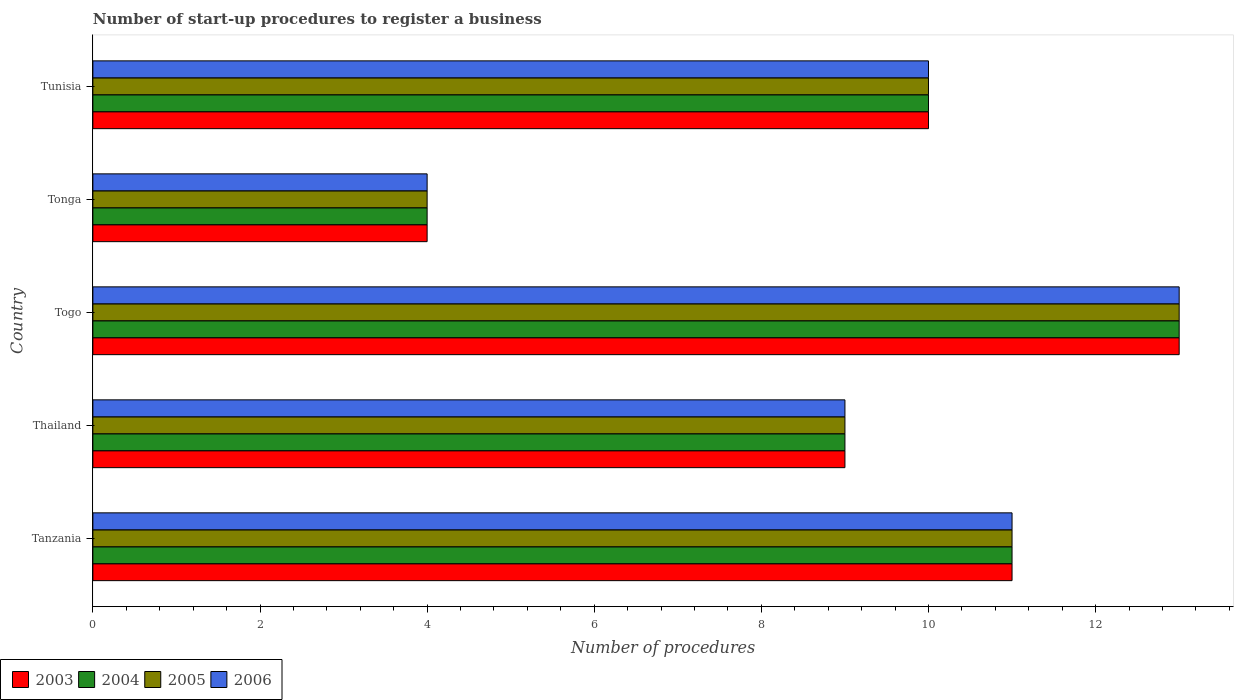How many groups of bars are there?
Your answer should be compact. 5. Are the number of bars per tick equal to the number of legend labels?
Give a very brief answer. Yes. How many bars are there on the 1st tick from the top?
Keep it short and to the point. 4. What is the label of the 5th group of bars from the top?
Offer a terse response. Tanzania. In how many cases, is the number of bars for a given country not equal to the number of legend labels?
Make the answer very short. 0. In which country was the number of procedures required to register a business in 2004 maximum?
Ensure brevity in your answer.  Togo. In which country was the number of procedures required to register a business in 2003 minimum?
Give a very brief answer. Tonga. What is the average number of procedures required to register a business in 2004 per country?
Give a very brief answer. 9.4. What is the difference between the number of procedures required to register a business in 2003 and number of procedures required to register a business in 2004 in Tunisia?
Offer a terse response. 0. Is the number of procedures required to register a business in 2005 in Tanzania less than that in Tunisia?
Ensure brevity in your answer.  No. Is the difference between the number of procedures required to register a business in 2003 in Tonga and Tunisia greater than the difference between the number of procedures required to register a business in 2004 in Tonga and Tunisia?
Your response must be concise. No. In how many countries, is the number of procedures required to register a business in 2006 greater than the average number of procedures required to register a business in 2006 taken over all countries?
Your answer should be compact. 3. What does the 3rd bar from the bottom in Tonga represents?
Offer a terse response. 2005. Is it the case that in every country, the sum of the number of procedures required to register a business in 2003 and number of procedures required to register a business in 2006 is greater than the number of procedures required to register a business in 2004?
Ensure brevity in your answer.  Yes. Are all the bars in the graph horizontal?
Your answer should be compact. Yes. Are the values on the major ticks of X-axis written in scientific E-notation?
Provide a short and direct response. No. Does the graph contain grids?
Your response must be concise. No. What is the title of the graph?
Make the answer very short. Number of start-up procedures to register a business. Does "1971" appear as one of the legend labels in the graph?
Ensure brevity in your answer.  No. What is the label or title of the X-axis?
Provide a short and direct response. Number of procedures. What is the Number of procedures in 2004 in Tanzania?
Ensure brevity in your answer.  11. What is the Number of procedures in 2005 in Thailand?
Offer a very short reply. 9. What is the Number of procedures of 2006 in Thailand?
Offer a very short reply. 9. What is the Number of procedures of 2003 in Togo?
Provide a succinct answer. 13. What is the Number of procedures of 2004 in Togo?
Ensure brevity in your answer.  13. What is the Number of procedures of 2006 in Togo?
Provide a short and direct response. 13. What is the Number of procedures in 2004 in Tonga?
Give a very brief answer. 4. What is the Number of procedures in 2005 in Tonga?
Provide a short and direct response. 4. What is the Number of procedures in 2006 in Tonga?
Give a very brief answer. 4. What is the Number of procedures of 2003 in Tunisia?
Provide a succinct answer. 10. Across all countries, what is the maximum Number of procedures of 2005?
Your response must be concise. 13. Across all countries, what is the maximum Number of procedures of 2006?
Give a very brief answer. 13. Across all countries, what is the minimum Number of procedures in 2003?
Ensure brevity in your answer.  4. Across all countries, what is the minimum Number of procedures of 2005?
Offer a terse response. 4. Across all countries, what is the minimum Number of procedures of 2006?
Provide a short and direct response. 4. What is the total Number of procedures of 2003 in the graph?
Provide a short and direct response. 47. What is the total Number of procedures of 2005 in the graph?
Offer a very short reply. 47. What is the difference between the Number of procedures in 2003 in Tanzania and that in Thailand?
Provide a short and direct response. 2. What is the difference between the Number of procedures of 2005 in Tanzania and that in Thailand?
Keep it short and to the point. 2. What is the difference between the Number of procedures in 2006 in Tanzania and that in Thailand?
Your response must be concise. 2. What is the difference between the Number of procedures of 2003 in Tanzania and that in Tonga?
Your answer should be compact. 7. What is the difference between the Number of procedures of 2005 in Tanzania and that in Tonga?
Your answer should be very brief. 7. What is the difference between the Number of procedures in 2006 in Tanzania and that in Tonga?
Give a very brief answer. 7. What is the difference between the Number of procedures in 2004 in Tanzania and that in Tunisia?
Offer a terse response. 1. What is the difference between the Number of procedures of 2005 in Tanzania and that in Tunisia?
Offer a very short reply. 1. What is the difference between the Number of procedures of 2006 in Tanzania and that in Tunisia?
Provide a short and direct response. 1. What is the difference between the Number of procedures in 2003 in Thailand and that in Togo?
Give a very brief answer. -4. What is the difference between the Number of procedures in 2006 in Thailand and that in Togo?
Your answer should be very brief. -4. What is the difference between the Number of procedures of 2006 in Thailand and that in Tunisia?
Give a very brief answer. -1. What is the difference between the Number of procedures of 2003 in Togo and that in Tonga?
Provide a short and direct response. 9. What is the difference between the Number of procedures in 2003 in Togo and that in Tunisia?
Provide a succinct answer. 3. What is the difference between the Number of procedures in 2005 in Togo and that in Tunisia?
Make the answer very short. 3. What is the difference between the Number of procedures in 2004 in Tonga and that in Tunisia?
Your response must be concise. -6. What is the difference between the Number of procedures of 2005 in Tonga and that in Tunisia?
Offer a very short reply. -6. What is the difference between the Number of procedures in 2003 in Tanzania and the Number of procedures in 2004 in Thailand?
Provide a succinct answer. 2. What is the difference between the Number of procedures of 2005 in Tanzania and the Number of procedures of 2006 in Thailand?
Your answer should be compact. 2. What is the difference between the Number of procedures of 2003 in Tanzania and the Number of procedures of 2004 in Togo?
Offer a terse response. -2. What is the difference between the Number of procedures in 2003 in Tanzania and the Number of procedures in 2005 in Togo?
Provide a short and direct response. -2. What is the difference between the Number of procedures in 2003 in Tanzania and the Number of procedures in 2006 in Togo?
Provide a short and direct response. -2. What is the difference between the Number of procedures of 2004 in Tanzania and the Number of procedures of 2005 in Togo?
Your answer should be compact. -2. What is the difference between the Number of procedures in 2003 in Tanzania and the Number of procedures in 2006 in Tonga?
Your response must be concise. 7. What is the difference between the Number of procedures of 2004 in Tanzania and the Number of procedures of 2005 in Tonga?
Provide a succinct answer. 7. What is the difference between the Number of procedures in 2003 in Tanzania and the Number of procedures in 2006 in Tunisia?
Make the answer very short. 1. What is the difference between the Number of procedures of 2005 in Tanzania and the Number of procedures of 2006 in Tunisia?
Offer a terse response. 1. What is the difference between the Number of procedures in 2003 in Thailand and the Number of procedures in 2004 in Togo?
Offer a terse response. -4. What is the difference between the Number of procedures of 2003 in Thailand and the Number of procedures of 2005 in Togo?
Ensure brevity in your answer.  -4. What is the difference between the Number of procedures of 2003 in Thailand and the Number of procedures of 2006 in Togo?
Ensure brevity in your answer.  -4. What is the difference between the Number of procedures in 2004 in Thailand and the Number of procedures in 2006 in Togo?
Your response must be concise. -4. What is the difference between the Number of procedures of 2003 in Thailand and the Number of procedures of 2006 in Tonga?
Provide a short and direct response. 5. What is the difference between the Number of procedures of 2004 in Thailand and the Number of procedures of 2005 in Tonga?
Ensure brevity in your answer.  5. What is the difference between the Number of procedures in 2004 in Thailand and the Number of procedures in 2006 in Tonga?
Offer a terse response. 5. What is the difference between the Number of procedures of 2005 in Thailand and the Number of procedures of 2006 in Tonga?
Your answer should be very brief. 5. What is the difference between the Number of procedures in 2003 in Thailand and the Number of procedures in 2004 in Tunisia?
Provide a succinct answer. -1. What is the difference between the Number of procedures in 2003 in Thailand and the Number of procedures in 2005 in Tunisia?
Offer a terse response. -1. What is the difference between the Number of procedures in 2003 in Togo and the Number of procedures in 2004 in Tonga?
Make the answer very short. 9. What is the difference between the Number of procedures in 2003 in Togo and the Number of procedures in 2006 in Tonga?
Ensure brevity in your answer.  9. What is the difference between the Number of procedures of 2005 in Togo and the Number of procedures of 2006 in Tonga?
Offer a terse response. 9. What is the difference between the Number of procedures of 2003 in Togo and the Number of procedures of 2005 in Tunisia?
Offer a very short reply. 3. What is the difference between the Number of procedures of 2004 in Togo and the Number of procedures of 2005 in Tunisia?
Your answer should be very brief. 3. What is the difference between the Number of procedures in 2005 in Togo and the Number of procedures in 2006 in Tunisia?
Your answer should be very brief. 3. What is the difference between the Number of procedures of 2003 in Tonga and the Number of procedures of 2004 in Tunisia?
Provide a succinct answer. -6. What is the average Number of procedures of 2004 per country?
Offer a terse response. 9.4. What is the average Number of procedures of 2006 per country?
Keep it short and to the point. 9.4. What is the difference between the Number of procedures in 2003 and Number of procedures in 2004 in Tanzania?
Offer a very short reply. 0. What is the difference between the Number of procedures of 2003 and Number of procedures of 2005 in Tanzania?
Provide a short and direct response. 0. What is the difference between the Number of procedures of 2003 and Number of procedures of 2006 in Tanzania?
Provide a succinct answer. 0. What is the difference between the Number of procedures of 2004 and Number of procedures of 2006 in Tanzania?
Your response must be concise. 0. What is the difference between the Number of procedures of 2003 and Number of procedures of 2005 in Thailand?
Keep it short and to the point. 0. What is the difference between the Number of procedures in 2004 and Number of procedures in 2005 in Thailand?
Your answer should be compact. 0. What is the difference between the Number of procedures in 2004 and Number of procedures in 2006 in Thailand?
Provide a short and direct response. 0. What is the difference between the Number of procedures of 2004 and Number of procedures of 2006 in Togo?
Your response must be concise. 0. What is the difference between the Number of procedures of 2003 and Number of procedures of 2004 in Tonga?
Offer a very short reply. 0. What is the difference between the Number of procedures in 2003 and Number of procedures in 2005 in Tonga?
Keep it short and to the point. 0. What is the difference between the Number of procedures of 2003 and Number of procedures of 2006 in Tonga?
Your answer should be compact. 0. What is the difference between the Number of procedures in 2005 and Number of procedures in 2006 in Tonga?
Make the answer very short. 0. What is the difference between the Number of procedures of 2004 and Number of procedures of 2005 in Tunisia?
Give a very brief answer. 0. What is the difference between the Number of procedures of 2004 and Number of procedures of 2006 in Tunisia?
Provide a short and direct response. 0. What is the difference between the Number of procedures of 2005 and Number of procedures of 2006 in Tunisia?
Ensure brevity in your answer.  0. What is the ratio of the Number of procedures in 2003 in Tanzania to that in Thailand?
Offer a terse response. 1.22. What is the ratio of the Number of procedures of 2004 in Tanzania to that in Thailand?
Offer a terse response. 1.22. What is the ratio of the Number of procedures of 2005 in Tanzania to that in Thailand?
Provide a short and direct response. 1.22. What is the ratio of the Number of procedures of 2006 in Tanzania to that in Thailand?
Offer a very short reply. 1.22. What is the ratio of the Number of procedures in 2003 in Tanzania to that in Togo?
Provide a succinct answer. 0.85. What is the ratio of the Number of procedures in 2004 in Tanzania to that in Togo?
Keep it short and to the point. 0.85. What is the ratio of the Number of procedures of 2005 in Tanzania to that in Togo?
Keep it short and to the point. 0.85. What is the ratio of the Number of procedures of 2006 in Tanzania to that in Togo?
Your response must be concise. 0.85. What is the ratio of the Number of procedures in 2003 in Tanzania to that in Tonga?
Provide a short and direct response. 2.75. What is the ratio of the Number of procedures in 2004 in Tanzania to that in Tonga?
Provide a succinct answer. 2.75. What is the ratio of the Number of procedures of 2005 in Tanzania to that in Tonga?
Keep it short and to the point. 2.75. What is the ratio of the Number of procedures in 2006 in Tanzania to that in Tonga?
Your response must be concise. 2.75. What is the ratio of the Number of procedures in 2006 in Tanzania to that in Tunisia?
Offer a very short reply. 1.1. What is the ratio of the Number of procedures in 2003 in Thailand to that in Togo?
Give a very brief answer. 0.69. What is the ratio of the Number of procedures of 2004 in Thailand to that in Togo?
Your answer should be compact. 0.69. What is the ratio of the Number of procedures in 2005 in Thailand to that in Togo?
Your answer should be compact. 0.69. What is the ratio of the Number of procedures of 2006 in Thailand to that in Togo?
Ensure brevity in your answer.  0.69. What is the ratio of the Number of procedures of 2003 in Thailand to that in Tonga?
Give a very brief answer. 2.25. What is the ratio of the Number of procedures of 2004 in Thailand to that in Tonga?
Offer a terse response. 2.25. What is the ratio of the Number of procedures of 2005 in Thailand to that in Tonga?
Provide a succinct answer. 2.25. What is the ratio of the Number of procedures of 2006 in Thailand to that in Tonga?
Your answer should be compact. 2.25. What is the ratio of the Number of procedures of 2003 in Thailand to that in Tunisia?
Make the answer very short. 0.9. What is the ratio of the Number of procedures of 2005 in Thailand to that in Tunisia?
Offer a very short reply. 0.9. What is the ratio of the Number of procedures of 2006 in Thailand to that in Tunisia?
Make the answer very short. 0.9. What is the ratio of the Number of procedures in 2005 in Togo to that in Tonga?
Offer a terse response. 3.25. What is the ratio of the Number of procedures of 2006 in Togo to that in Tonga?
Make the answer very short. 3.25. What is the ratio of the Number of procedures of 2003 in Togo to that in Tunisia?
Keep it short and to the point. 1.3. What is the ratio of the Number of procedures in 2004 in Togo to that in Tunisia?
Your answer should be compact. 1.3. What is the ratio of the Number of procedures in 2005 in Tonga to that in Tunisia?
Offer a terse response. 0.4. What is the ratio of the Number of procedures of 2006 in Tonga to that in Tunisia?
Keep it short and to the point. 0.4. What is the difference between the highest and the second highest Number of procedures in 2003?
Your response must be concise. 2. What is the difference between the highest and the second highest Number of procedures of 2005?
Your answer should be compact. 2. What is the difference between the highest and the second highest Number of procedures in 2006?
Your answer should be compact. 2. What is the difference between the highest and the lowest Number of procedures of 2006?
Your response must be concise. 9. 